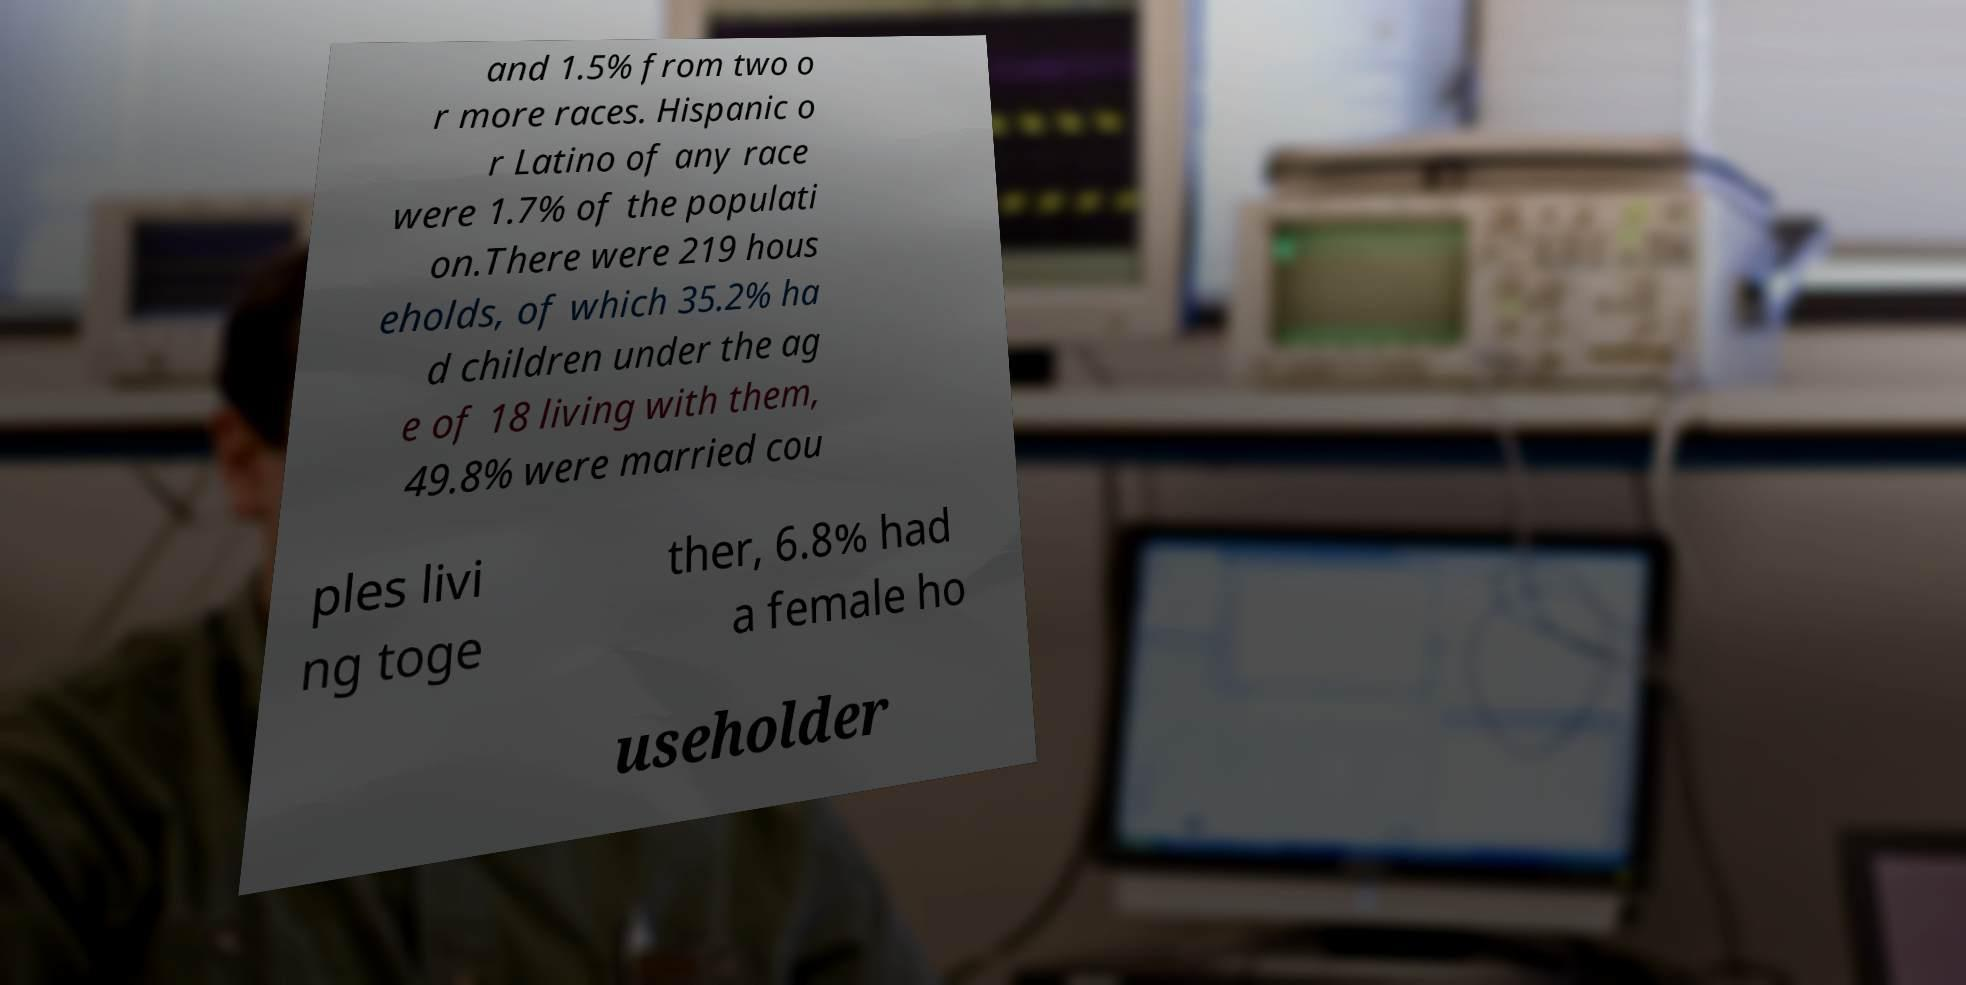Can you read and provide the text displayed in the image?This photo seems to have some interesting text. Can you extract and type it out for me? and 1.5% from two o r more races. Hispanic o r Latino of any race were 1.7% of the populati on.There were 219 hous eholds, of which 35.2% ha d children under the ag e of 18 living with them, 49.8% were married cou ples livi ng toge ther, 6.8% had a female ho useholder 